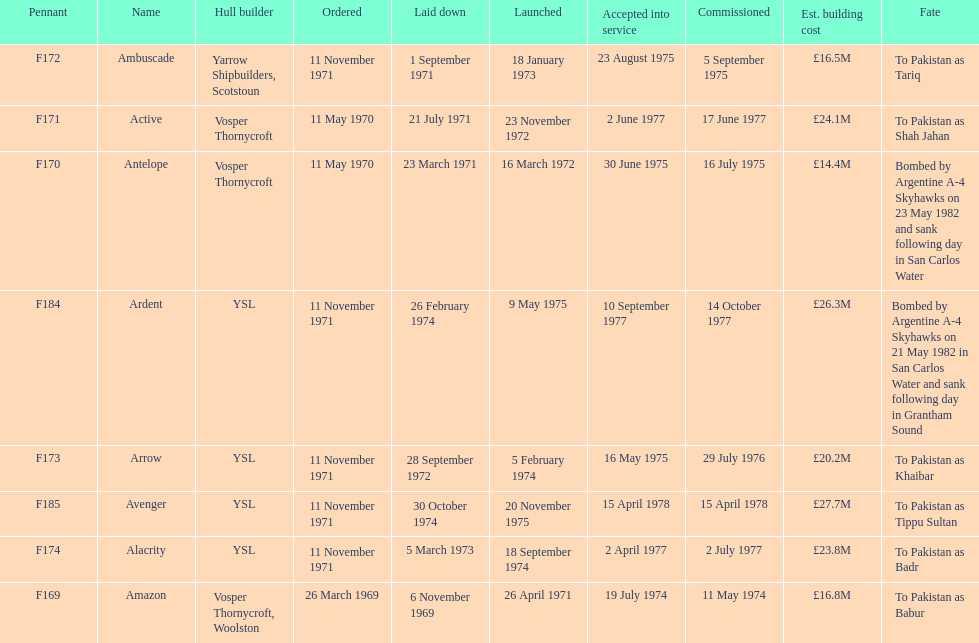What is the next pennant after f172? F173. 